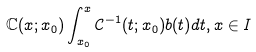<formula> <loc_0><loc_0><loc_500><loc_500>\mathbb { C } ( x ; x _ { 0 } ) \int _ { x _ { 0 } } ^ { x } \mathcal { C } ^ { - 1 } ( t ; x _ { 0 } ) b ( t ) d t , x \in I</formula> 